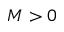Convert formula to latex. <formula><loc_0><loc_0><loc_500><loc_500>M > 0</formula> 